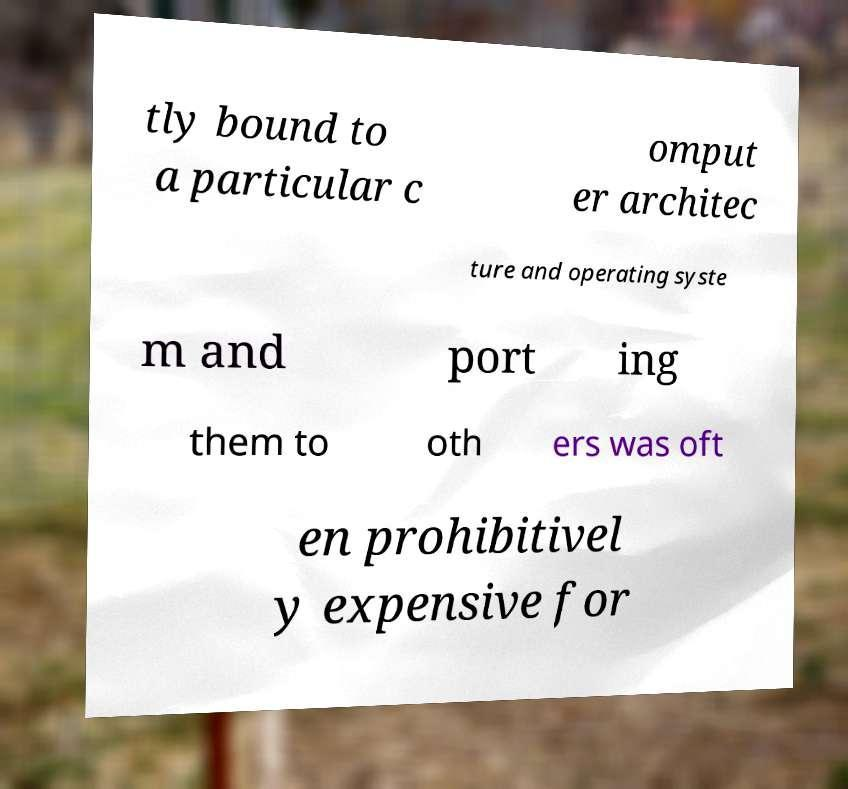Please read and relay the text visible in this image. What does it say? tly bound to a particular c omput er architec ture and operating syste m and port ing them to oth ers was oft en prohibitivel y expensive for 